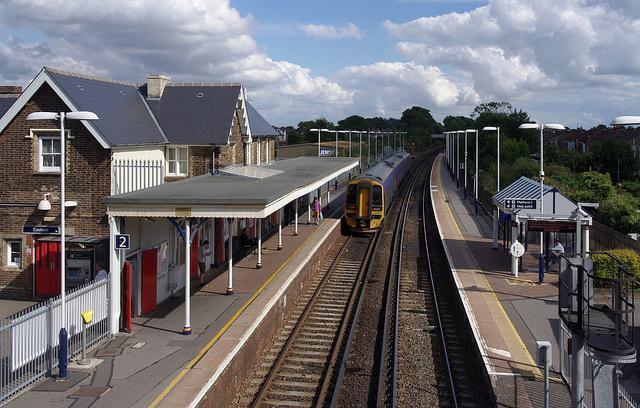How many sets of train tracks are next to these buildings?
Give a very brief answer. 2. How many birds are going to fly there in the image?
Give a very brief answer. 0. 